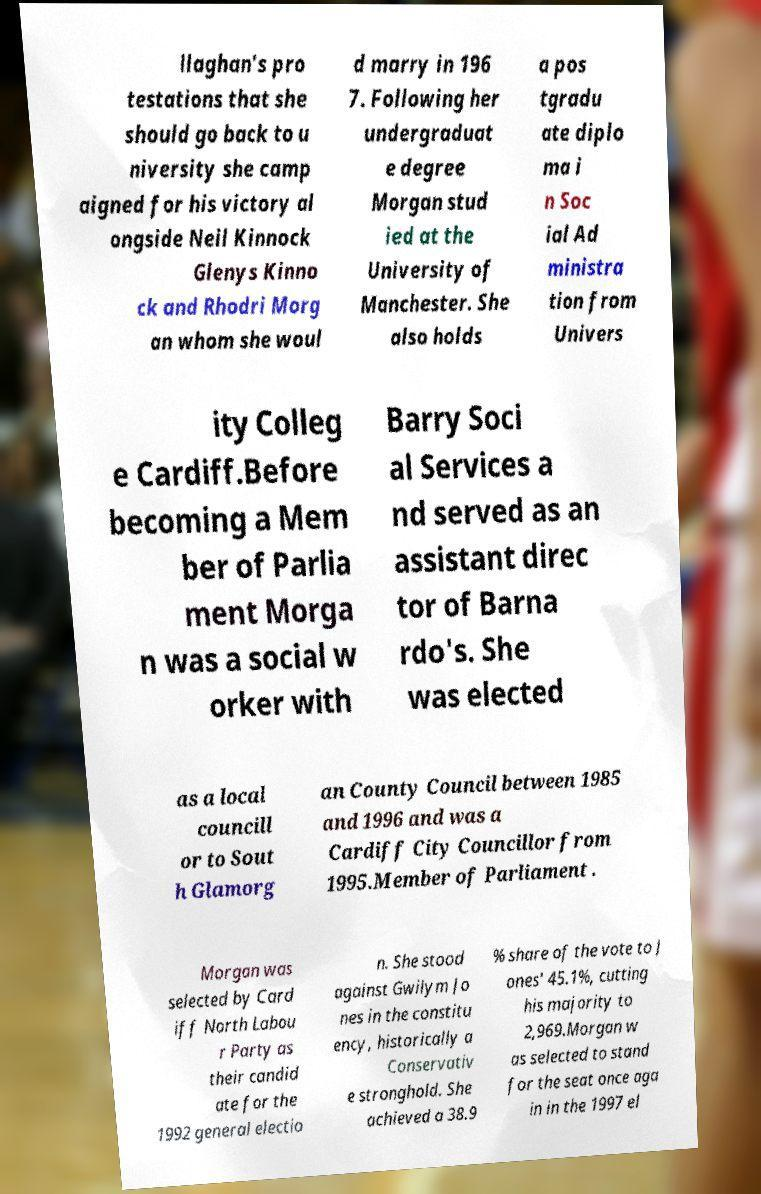Can you read and provide the text displayed in the image?This photo seems to have some interesting text. Can you extract and type it out for me? llaghan's pro testations that she should go back to u niversity she camp aigned for his victory al ongside Neil Kinnock Glenys Kinno ck and Rhodri Morg an whom she woul d marry in 196 7. Following her undergraduat e degree Morgan stud ied at the University of Manchester. She also holds a pos tgradu ate diplo ma i n Soc ial Ad ministra tion from Univers ity Colleg e Cardiff.Before becoming a Mem ber of Parlia ment Morga n was a social w orker with Barry Soci al Services a nd served as an assistant direc tor of Barna rdo's. She was elected as a local councill or to Sout h Glamorg an County Council between 1985 and 1996 and was a Cardiff City Councillor from 1995.Member of Parliament . Morgan was selected by Card iff North Labou r Party as their candid ate for the 1992 general electio n. She stood against Gwilym Jo nes in the constitu ency, historically a Conservativ e stronghold. She achieved a 38.9 % share of the vote to J ones' 45.1%, cutting his majority to 2,969.Morgan w as selected to stand for the seat once aga in in the 1997 el 